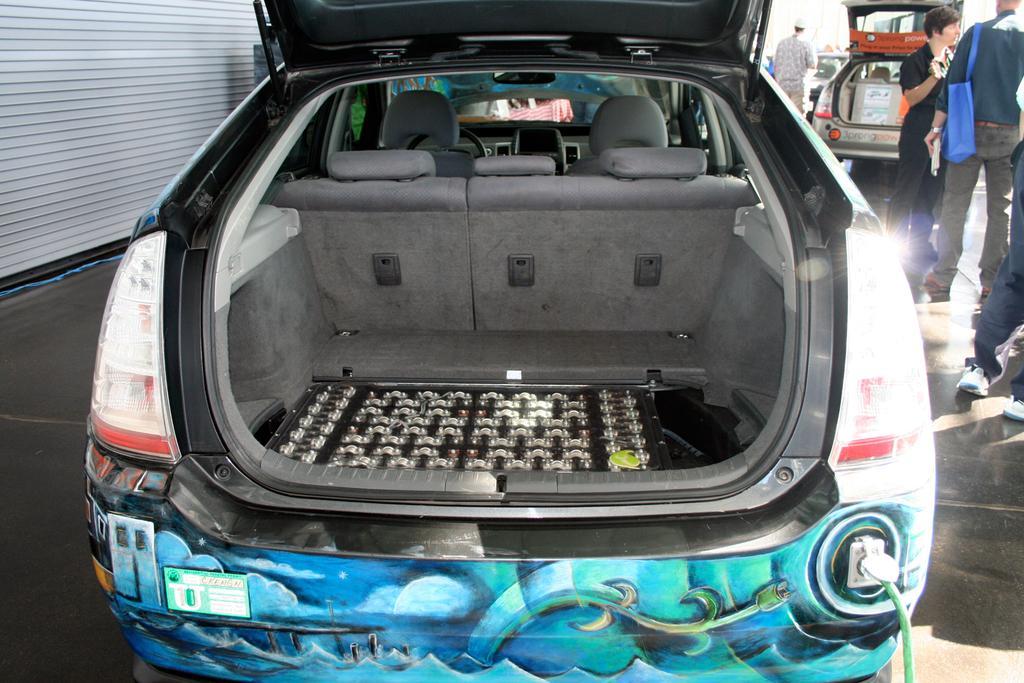Can you describe this image briefly? In the center of the image, we can see car's boot space and in the background, there is a wall and we can see some other vehicles and some people and one of them is wearing a bag and holding an object. At the bottom, there is floor. 